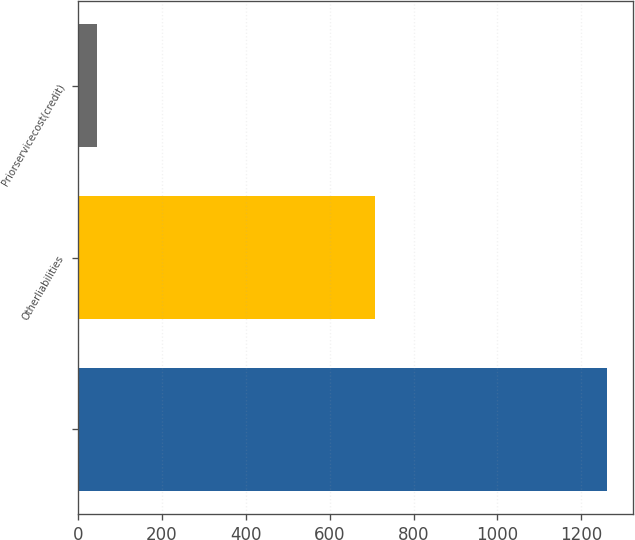<chart> <loc_0><loc_0><loc_500><loc_500><bar_chart><ecel><fcel>Otherliabilities<fcel>Priorservicecost(credit)<nl><fcel>1260.4<fcel>709<fcel>45<nl></chart> 